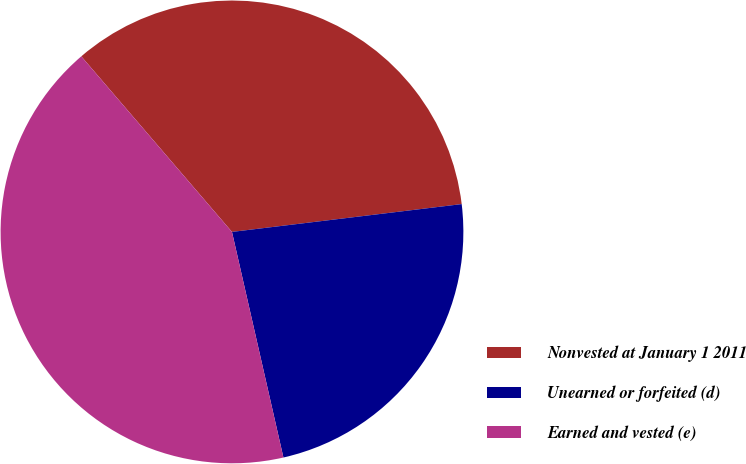Convert chart. <chart><loc_0><loc_0><loc_500><loc_500><pie_chart><fcel>Nonvested at January 1 2011<fcel>Unearned or forfeited (d)<fcel>Earned and vested (e)<nl><fcel>34.37%<fcel>23.35%<fcel>42.28%<nl></chart> 